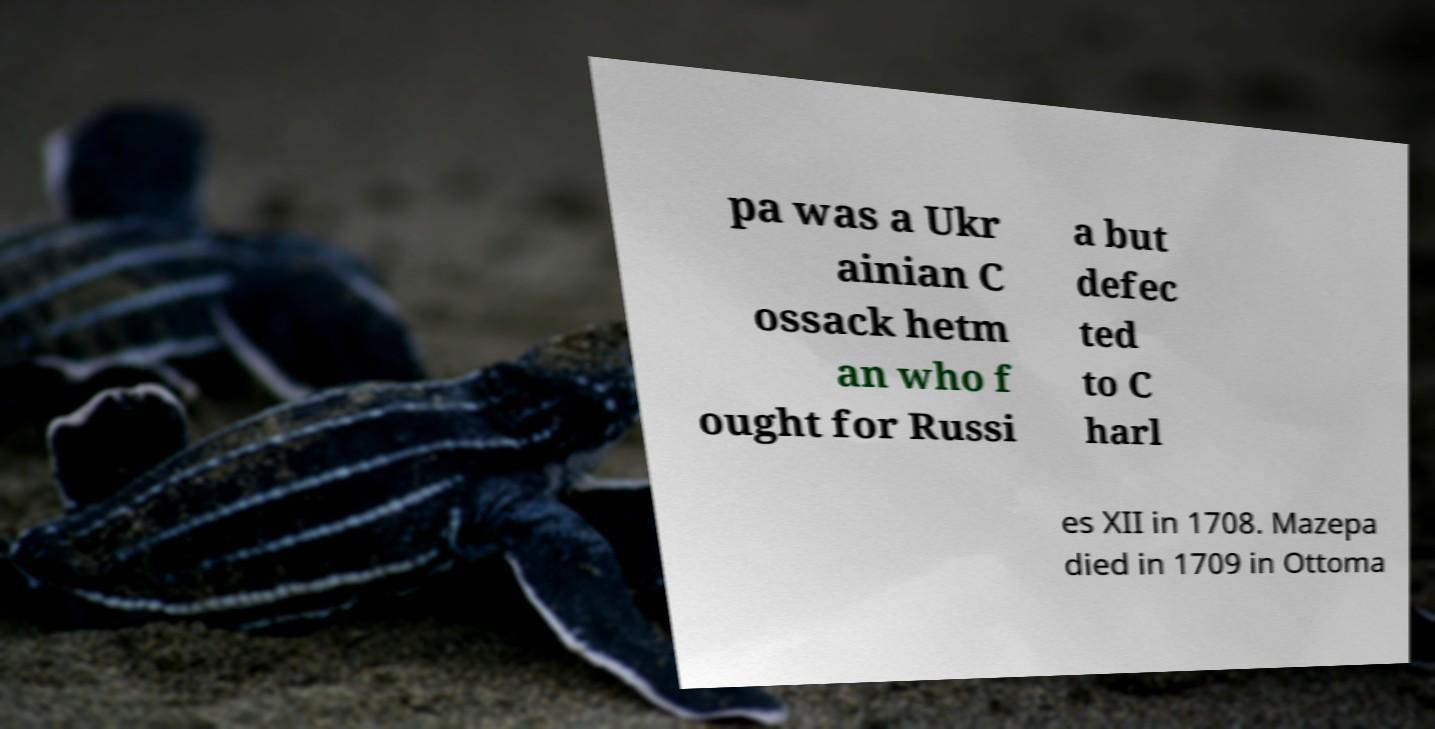Please identify and transcribe the text found in this image. pa was a Ukr ainian C ossack hetm an who f ought for Russi a but defec ted to C harl es XII in 1708. Mazepa died in 1709 in Ottoma 